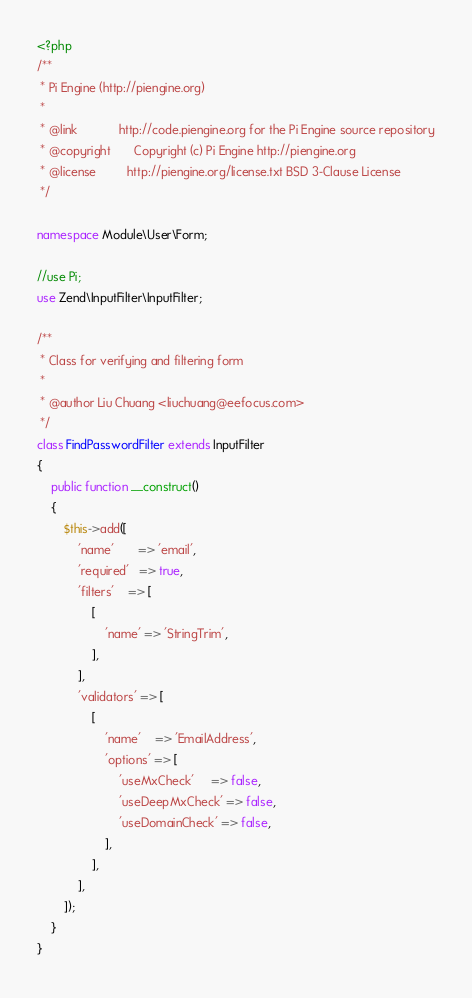<code> <loc_0><loc_0><loc_500><loc_500><_PHP_><?php
/**
 * Pi Engine (http://piengine.org)
 *
 * @link            http://code.piengine.org for the Pi Engine source repository
 * @copyright       Copyright (c) Pi Engine http://piengine.org
 * @license         http://piengine.org/license.txt BSD 3-Clause License
 */

namespace Module\User\Form;

//use Pi;
use Zend\InputFilter\InputFilter;

/**
 * Class for verifying and filtering form
 *
 * @author Liu Chuang <liuchuang@eefocus.com>
 */
class FindPasswordFilter extends InputFilter
{
    public function __construct()
    {
        $this->add([
            'name'       => 'email',
            'required'   => true,
            'filters'    => [
                [
                    'name' => 'StringTrim',
                ],
            ],
            'validators' => [
                [
                    'name'    => 'EmailAddress',
                    'options' => [
                        'useMxCheck'     => false,
                        'useDeepMxCheck' => false,
                        'useDomainCheck' => false,
                    ],
                ],
            ],
        ]);
    }
}</code> 